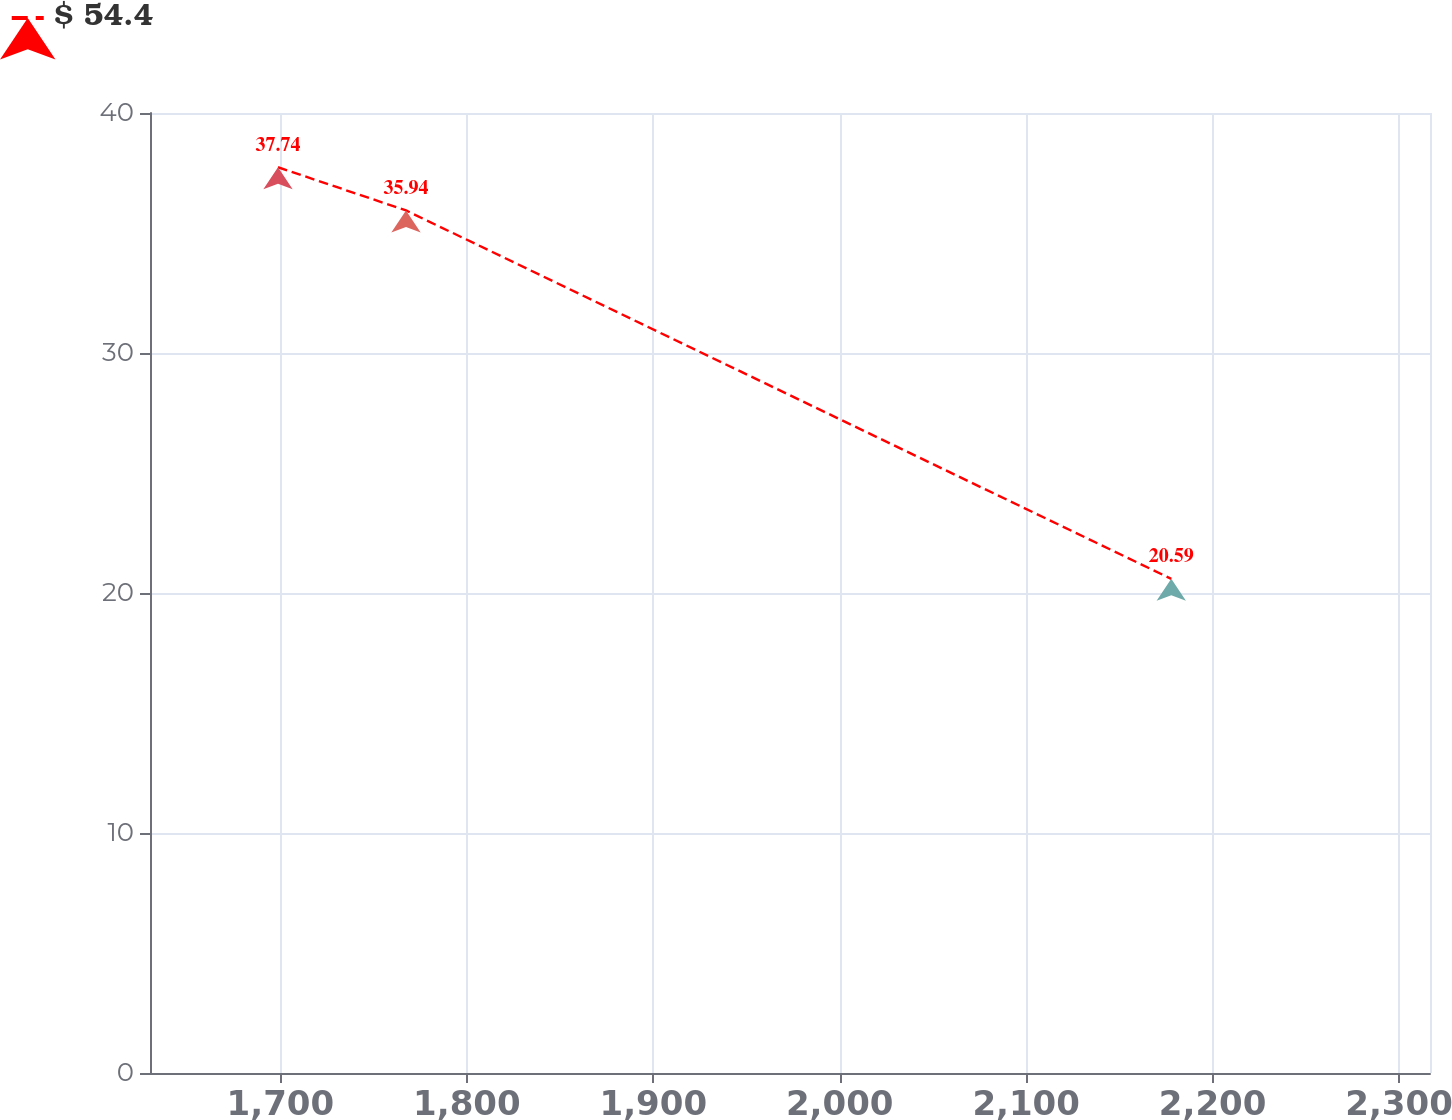Convert chart. <chart><loc_0><loc_0><loc_500><loc_500><line_chart><ecel><fcel>$ 54.4<nl><fcel>1698.72<fcel>37.74<nl><fcel>1767.37<fcel>35.94<nl><fcel>2177.83<fcel>20.59<nl><fcel>2385.25<fcel>18.76<nl></chart> 